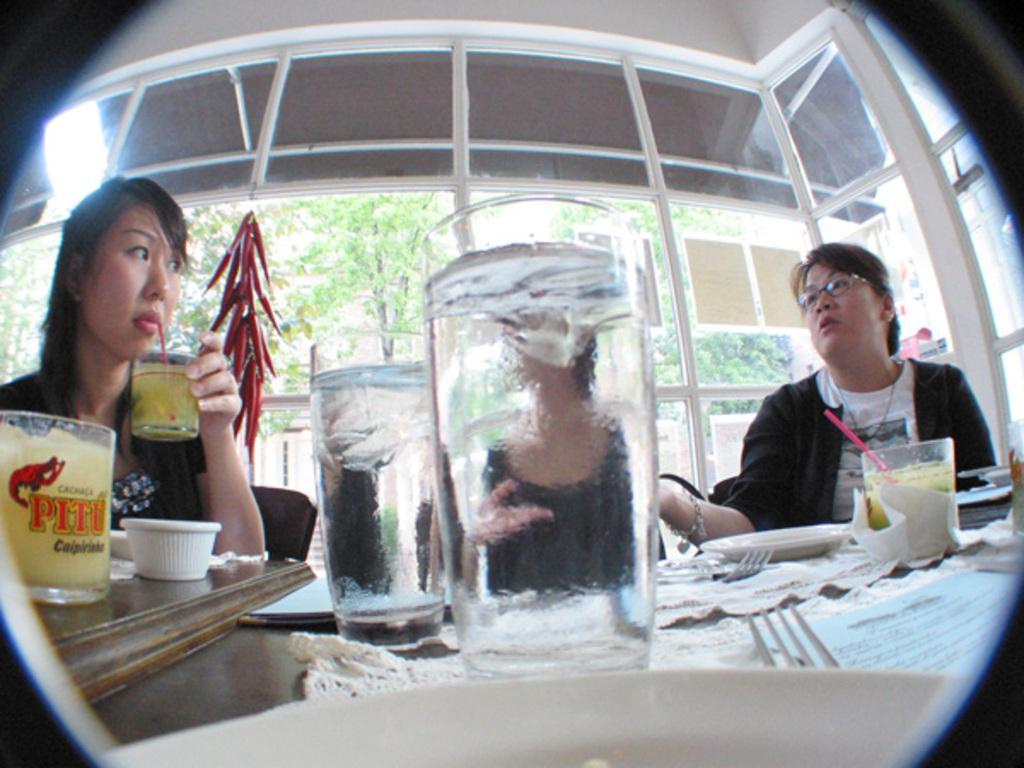Describe this image in one or two sentences. This picture seems to be an edited image. On the left there is a person sitting on the chair and holding a glass of drink and drinking. On the right there is another person sitting on the chair. In the foreground we can see a table on the top of which glasses of drinks and many other objects are placed. In the background we can see the trees and some other items. 